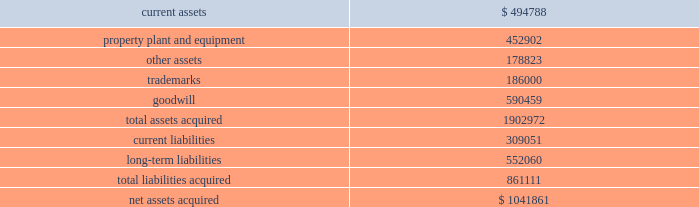Mondavi produces , markets and sells premium , super-premium and fine california wines under the woodbridge by robert mondavi , robert mondavi private selection and robert mondavi winery brand names .
Woodbridge and robert mondavi private selection are the leading premium and super-premium wine brands by volume , respectively , in the united states .
The acquisition of robert mondavi supports the company 2019s strategy of strengthening the breadth of its portfolio across price segments to capitalize on the overall growth in the pre- mium , super-premium and fine wine categories .
The company believes that the acquired robert mondavi brand names have strong brand recognition globally .
The vast majority of robert mondavi 2019s sales are generated in the united states .
The company intends to leverage the robert mondavi brands in the united states through its selling , marketing and distribution infrastructure .
The company also intends to further expand distribution for the robert mondavi brands in europe through its constellation europe infrastructure .
The company and robert mondavi have complementary busi- nesses that share a common growth orientation and operating philosophy .
The robert mondavi acquisition provides the company with a greater presence in the fine wine sector within the united states and the ability to capitalize on the broader geographic distribution in strategic international markets .
The robert mondavi acquisition supports the company 2019s strategy of growth and breadth across categories and geographies , and strengthens its competitive position in its core markets .
In par- ticular , the company believes there are growth opportunities for premium , super-premium and fine wines in the united kingdom , united states and other wine markets .
Total consid- eration paid in cash to the robert mondavi shareholders was $ 1030.7 million .
Additionally , the company expects to incur direct acquisition costs of $ 11.2 million .
The purchase price was financed with borrowings under the company 2019s 2004 credit agreement ( as defined in note 9 ) .
In accordance with the pur- chase method of accounting , the acquired net assets are recorded at fair value at the date of acquisition .
The purchase price was based primarily on the estimated future operating results of robert mondavi , including the factors described above , as well as an estimated benefit from operating cost synergies .
The results of operations of the robert mondavi business are reported in the constellation wines segment and have been included in the consolidated statement of income since the acquisition date .
The table summarizes the estimated fair values of the assets acquired and liabilities assumed in the robert mondavi acquisition at the date of acquisition .
The company is in the process of obtaining third-party valuations of certain assets and liabilities , and refining its restructuring plan which is under development and will be finalized during the company 2019s year ending february 28 , 2006 ( see note19 ) .
Accordingly , the allocation of the purchase price is subject to refinement .
Estimated fair values at december 22 , 2004 , are as follows : {in thousands} .
The trademarks are not subject to amortization .
None of the goodwill is expected to be deductible for tax purposes .
In connection with the robert mondavi acquisition and robert mondavi 2019s previously disclosed intention to sell certain of its winery properties and related assets , and other vineyard prop- erties , the company has classified certain assets as held for sale as of february 28 , 2005 .
The company expects to sell these assets during the year ended february 28 , 2006 , for net pro- ceeds of approximately $ 150 million to $ 175 million .
No gain or loss is expected to be recognized upon the sale of these assets .
Hardy acquisition 2013 on march 27 , 2003 , the company acquired control of brl hardy limited , now known as hardy wine company limited ( 201chardy 201d ) , and on april 9 , 2003 , the company completed its acquisition of all of hardy 2019s outstanding capital stock .
As a result of the acquisition of hardy , the company also acquired the remaining 50% ( 50 % ) ownership of pacific wine partners llc ( 201cpwp 201d ) , the joint venture the company established with hardy in july 2001 .
The acquisition of hardy along with the remaining interest in pwp is referred to together as the 201chardy acquisition . 201d through this acquisition , the company acquired one of australia 2019s largest wine producers with interests in winer- ies and vineyards in most of australia 2019s major wine regions as well as new zealand and the united states and hardy 2019s market- ing and sales operations in the united kingdom .
Total consideration paid in cash and class a common stock to the hardy shareholders was $ 1137.4 million .
Additionally , the company recorded direct acquisition costs of $ 17.2 million .
The acquisition date for accounting purposes is march 27 , 2003 .
The company has recorded a $ 1.6 million reduction in the purchase price to reflect imputed interest between the accounting acquisition date and the final payment of consider- ation .
This charge is included as interest expense in the consolidated statement of income for the year ended february 29 , 2004 .
The cash portion of the purchase price paid to the hardy shareholders and optionholders ( $ 1060.2 mil- lion ) was financed with $ 660.2 million of borrowings under the company 2019s then existing credit agreement and $ 400.0 million .
What is the current ratio for 2004? 
Computations: (494788 / 309051)
Answer: 1.60099. 